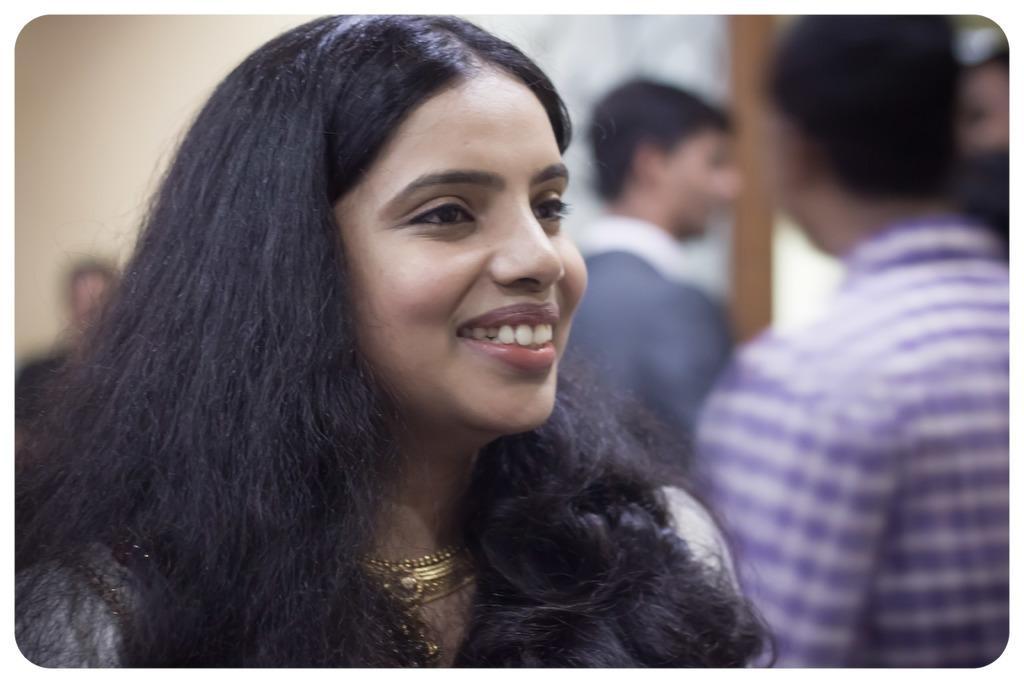How would you summarize this image in a sentence or two? In this image I can see few people. In front one person is smiling. Background is blurred. 